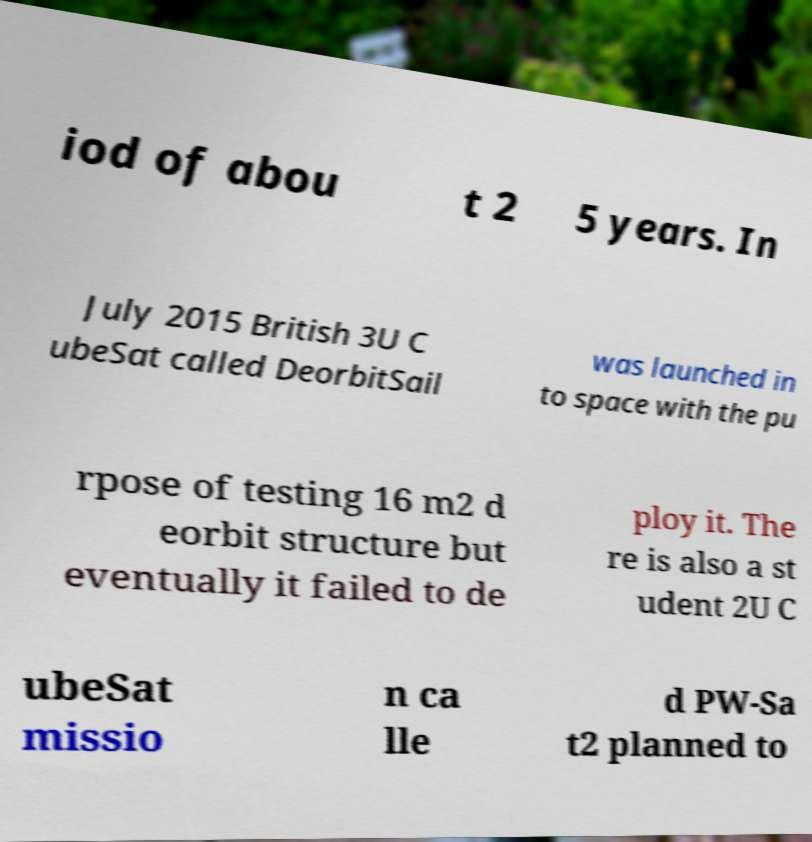I need the written content from this picture converted into text. Can you do that? iod of abou t 2 5 years. In July 2015 British 3U C ubeSat called DeorbitSail was launched in to space with the pu rpose of testing 16 m2 d eorbit structure but eventually it failed to de ploy it. The re is also a st udent 2U C ubeSat missio n ca lle d PW-Sa t2 planned to 